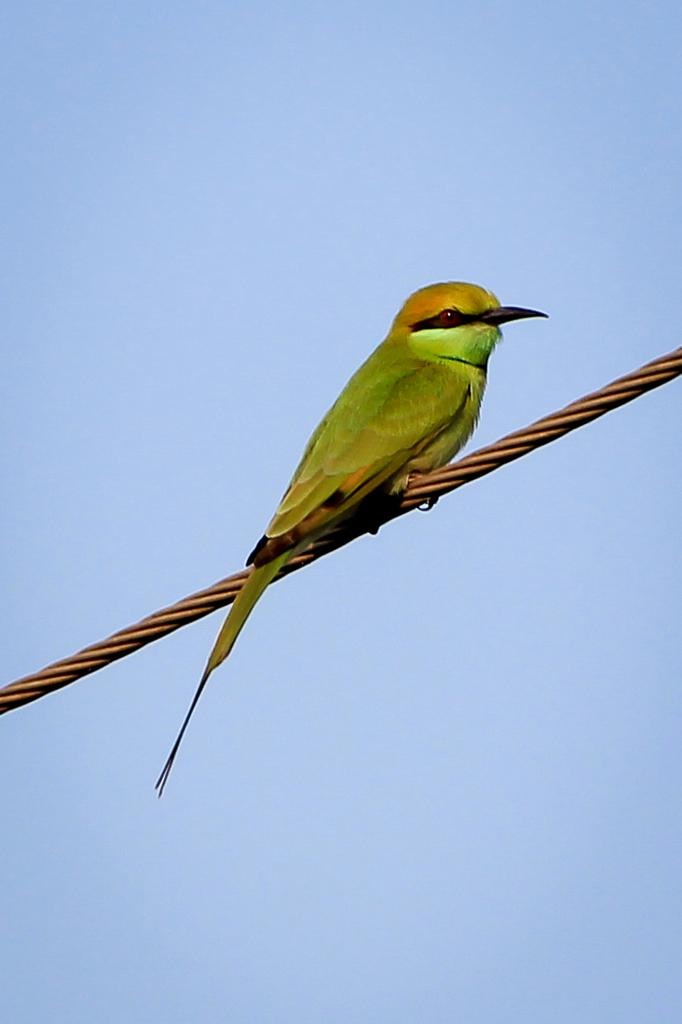What can be seen in the image that is made of a thin, flexible material? There is a wire in the image that is made of a thin, flexible material. What type of animal is sitting on the wire? A green-colored bird is present on the wire. What color is dominant in the background of the image? The background of the image includes blue color. What type of base is supporting the wire in the image? There is no base visible in the image; the wire is suspended in the air. 